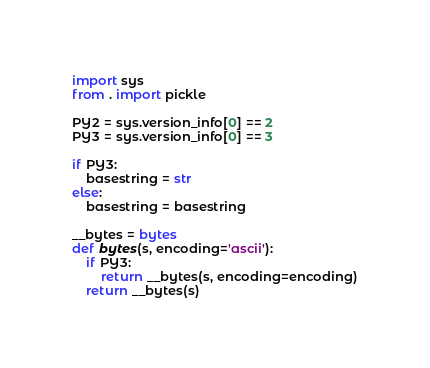<code> <loc_0><loc_0><loc_500><loc_500><_Python_>import sys
from . import pickle

PY2 = sys.version_info[0] == 2 
PY3 = sys.version_info[0] == 3 

if PY3: 
    basestring = str
else:
    basestring = basestring

__bytes = bytes
def bytes(s, encoding='ascii'):
    if PY3:
        return __bytes(s, encoding=encoding)
    return __bytes(s)

</code> 